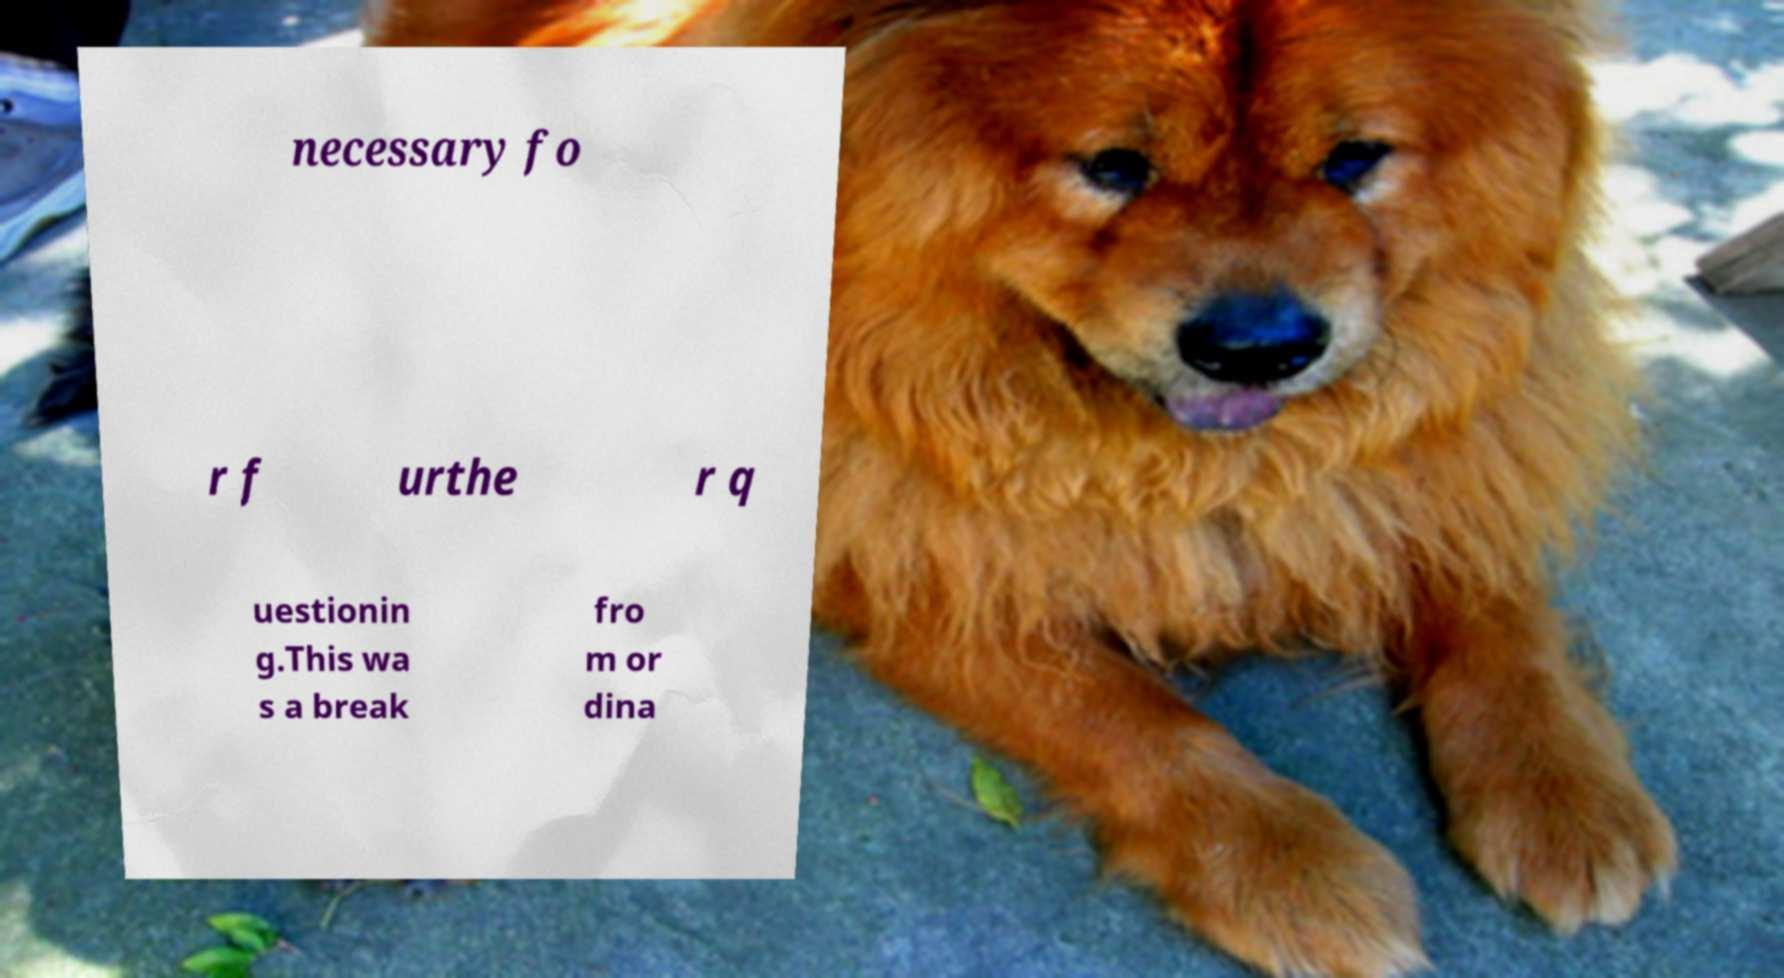I need the written content from this picture converted into text. Can you do that? necessary fo r f urthe r q uestionin g.This wa s a break fro m or dina 